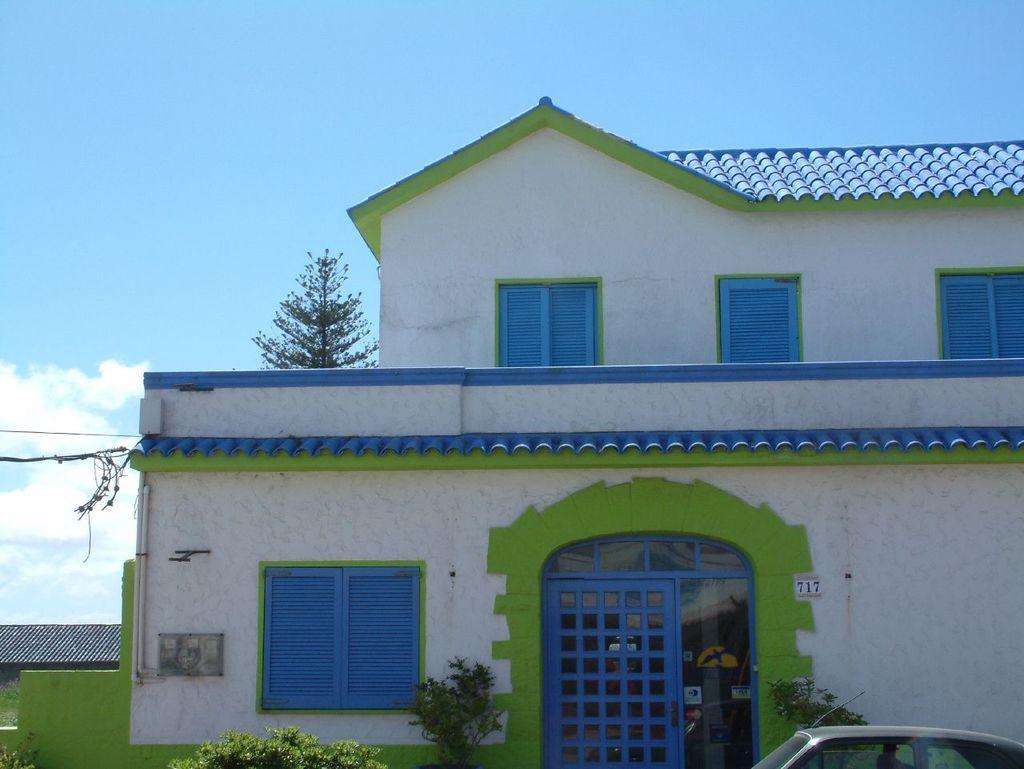Can you describe this image briefly? There is a house, it is of blue white and green color and in front of the house is a car and there are few plants in front of the house wall. 